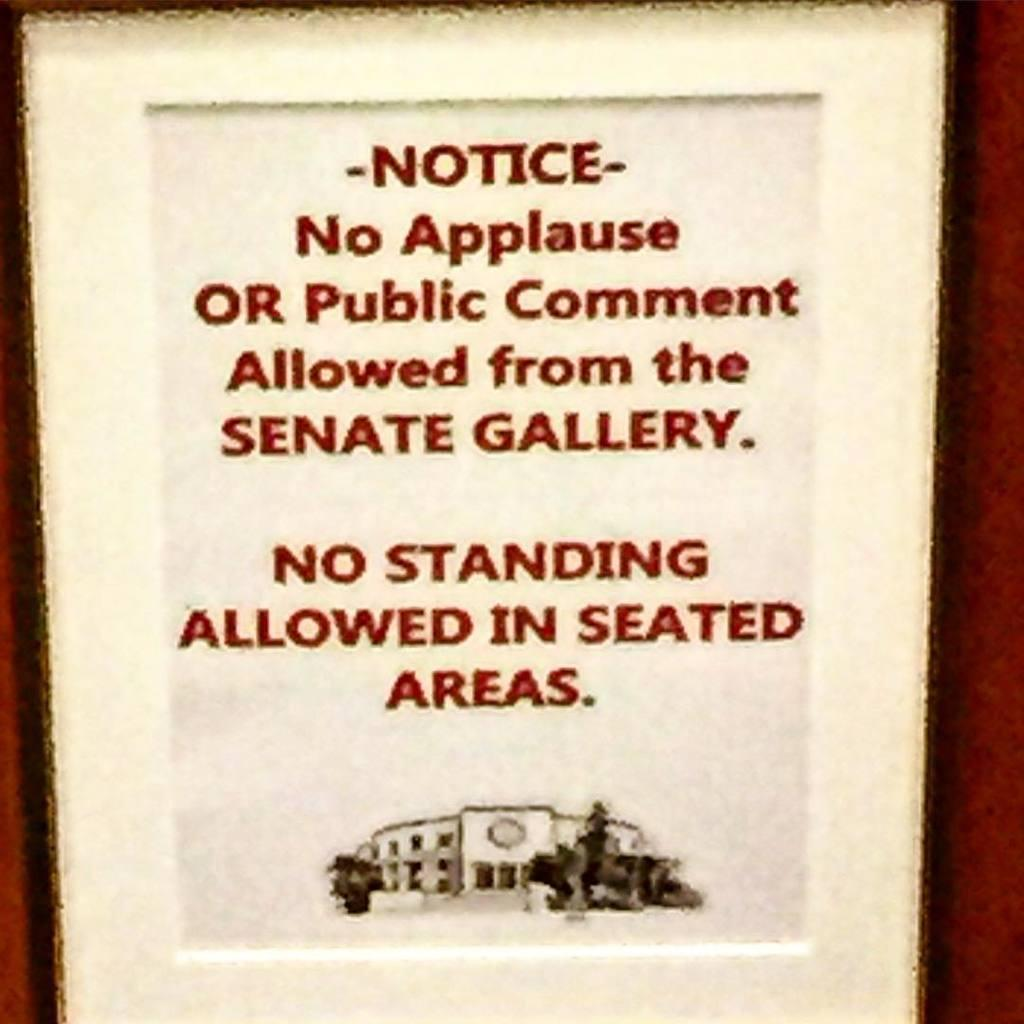<image>
Create a compact narrative representing the image presented. Sign on a wall that says the Notice in red letters. 